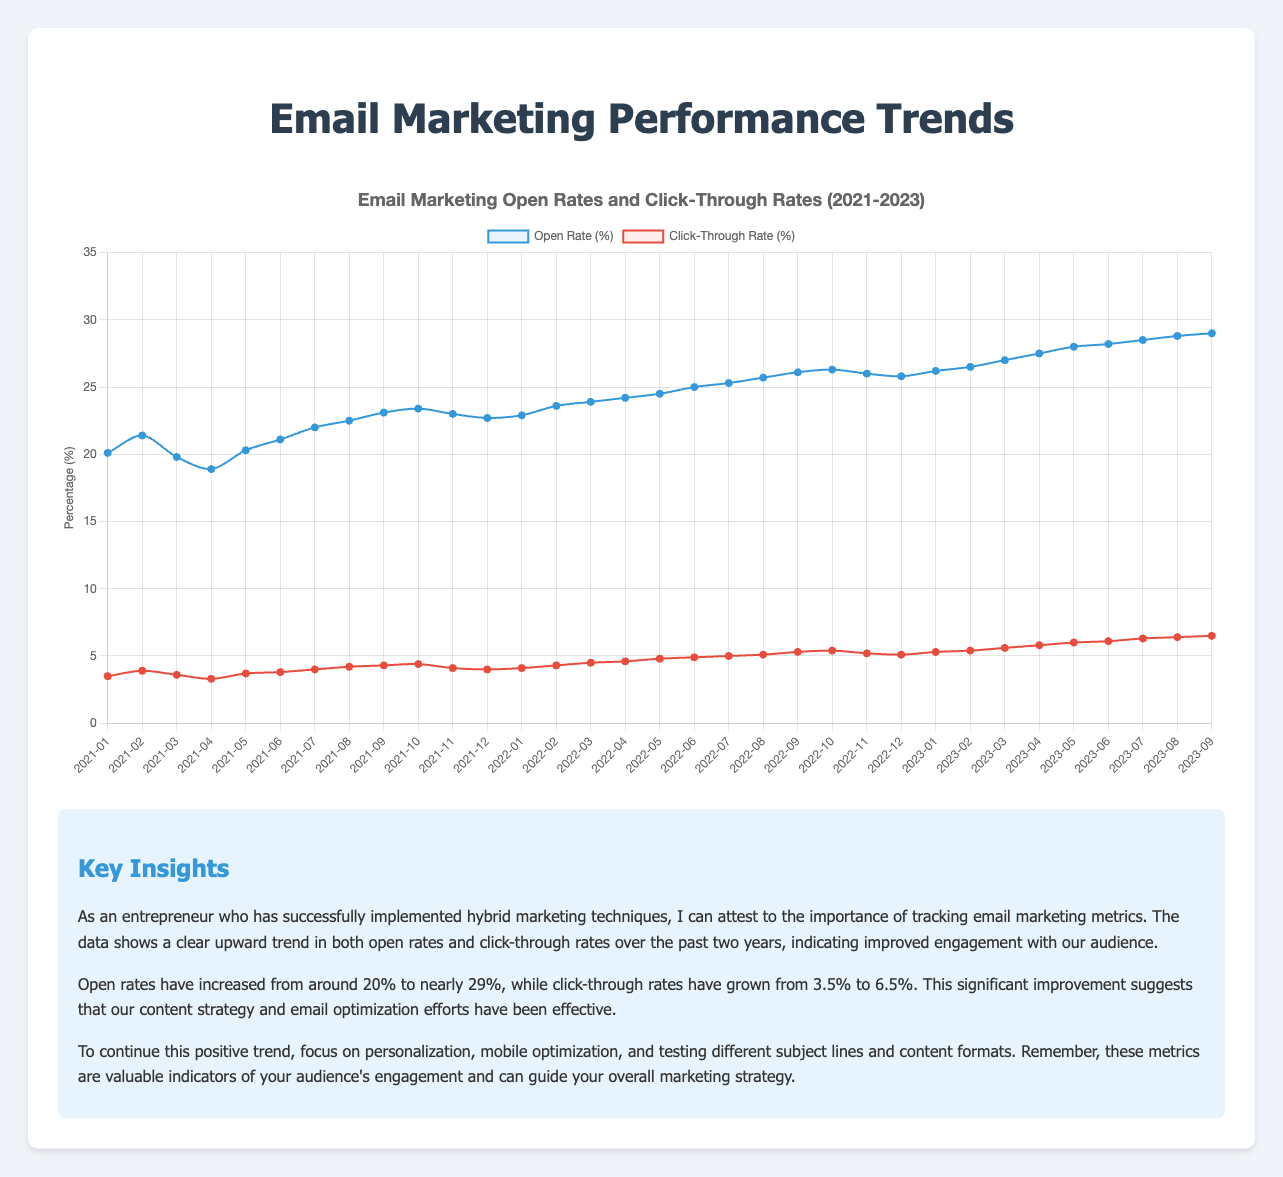What is the overall trend in open rates from January 2021 to September 2023? The overall trend for the open rates shows a consistent increase. Starting from 20.1% in January 2021, it rises steadily up to 29.0% in September 2023, indicating improved engagement over time.
Answer: Increasing How do the click-through rates in January 2021 compare to those in September 2023? In January 2021, the click-through rate was 3.5%. By September 2023, it had risen to 6.5%. This shows an increase of 3.0 percentage points over the period.
Answer: September 2023 is higher by 3.0 percentage points What were the highest open rate and the highest click-through rate observed in the given period? The highest open rate observed was 29.0% in September 2023. The highest click-through rate was 6.5%, also in September 2023.
Answer: 29.0% and 6.5% What is the average open rate from January 2021 to December 2021? The open rates for 2021 are: 20.1, 21.4, 19.8, 18.9, 20.3, 21.1, 22.0, 22.5, 23.1, 23.4, 23.0, and 22.7. Summing these gives 258.3, and dividing by 12 months, the average open rate is 258.3 / 12 = 21.525%.
Answer: 21.525% In which months did the open rates and click-through rates both show noticeable increases compared to the previous month? - April 2021 to May 2021: Open rates increased from 18.9% to 20.3%, and click-through rates increased from 3.3% to 3.7%. 
- June 2021 to July 2021: Open rates increased from 21.1% to 22.0%, and click-through rates increased from 3.8% to 4.0%.
- March 2023 to April 2023: Open rates increased from 27.0% to 27.5%, and click-through rates increased from 5.6% to 5.8%.
- April 2023 to May 2023: Open rates increased from 27.5% to 28.0%, and click-through rates increased from 5.8% to 6.0%.
Answer: May 2021, July 2021, April 2023, May 2023 How did the click-through rate change from January 2021 to December 2021? From January 2021 to December 2021, the click-through rate increased from 3.5% to 4.0%. It shows a gradual increase with some minor fluctuations throughout the year.
Answer: Increased from 3.5% to 4.0% Compare the open rate and click-through rate increase from January 2021 to January 2022. Which one had a more significant percentage increase? The open rate increased from 20.1% in January 2021 to 22.9% in January 2022, a 2.8 percentage point increase which is (2.8 / 20.1)*100 = 13.93%. The click-through rate increased from 3.5% to 4.1% in the same period, a 0.6 percentage point increase which is (0.6 / 3.5)*100 = 17.14%. The click-through rate had a more significant percentage increase.
Answer: Click-through rate In which month(s) did the open rate exceed 25% for the first time and thereafter consistently stay above it? The open rate first exceeded 25% in June 2022 (25.0%) and thereafter consistently stayed above it in all the following months.
Answer: June 2022 What is the range of the click-through rates from 2021-09 to 2022-09? The click-through rates from September 2021 to September 2022 are 4.3%, 4.4%, 4.1%, 4.0%, 4.1%, 4.3%, 4.5%, 4.6%, 4.8%, 4.9%, 5.0%, and 5.1%. The range is the difference between the highest (5.1%) and the lowest (4.0%) rate, which is 5.1% - 4.0% = 1.1%.
Answer: 1.1% Is there any month where both rates decreased compared to the previous month? If so, identify it. Yes, in November 2022 both open and click-through rates decreased compared to October 2022. The open rate dropped from 26.3% to 26.0%, and the click-through rate dropped from 5.4% to 5.2%.
Answer: November 2022 